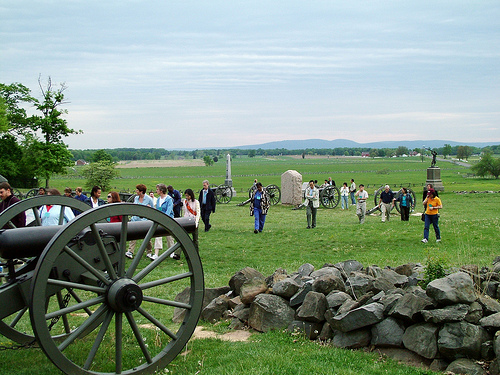<image>
Is the rock to the right of the grass? No. The rock is not to the right of the grass. The horizontal positioning shows a different relationship. 